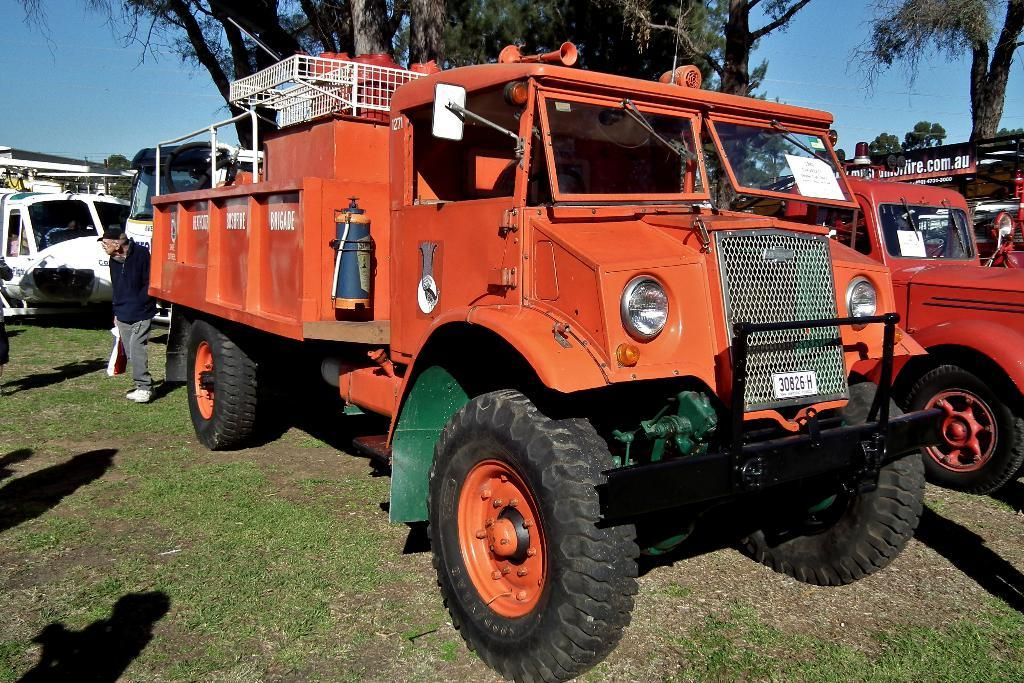What can be seen in the foreground of the picture? There are vehicles, grass, and a person in the foreground of the picture. What type of vegetation is present in the foreground? There is grass in the foreground of the picture. Can you describe the person in the foreground? There is a person in the foreground of the picture. What is in the middle of the picture? There are trees in the middle of the picture. What is visible in the background of the picture? The background of the picture is the sky. What type of learning is taking place in the picture? There is no indication of learning taking place in the picture. How many trees are present in the picture? The provided facts do not specify the exact number of trees in the picture, only that there are trees present. 